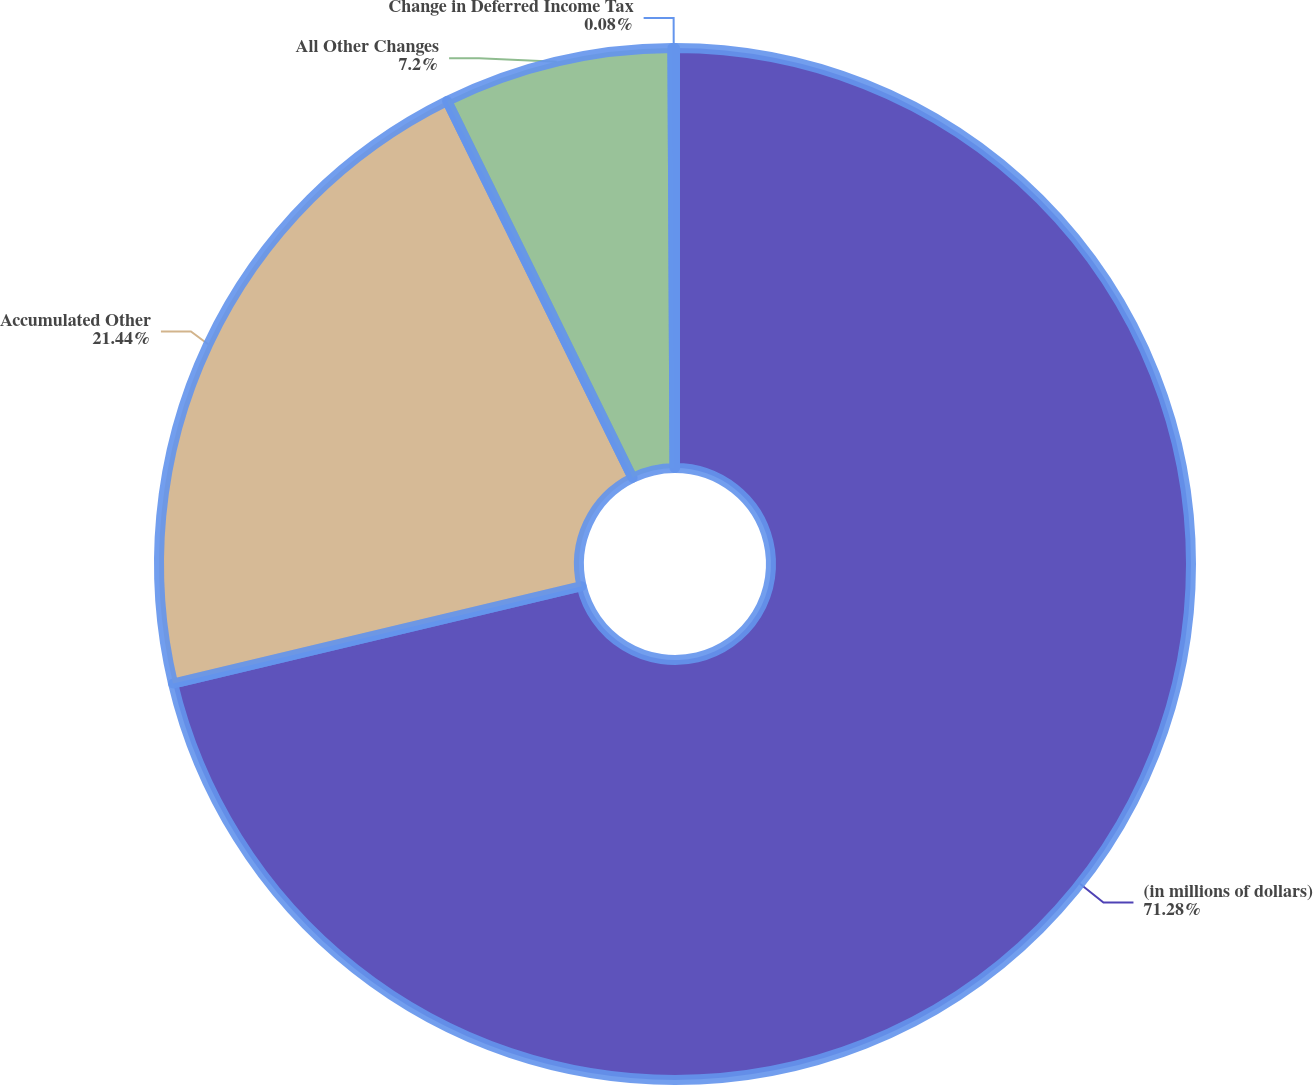Convert chart to OTSL. <chart><loc_0><loc_0><loc_500><loc_500><pie_chart><fcel>(in millions of dollars)<fcel>Accumulated Other<fcel>All Other Changes<fcel>Change in Deferred Income Tax<nl><fcel>71.28%<fcel>21.44%<fcel>7.2%<fcel>0.08%<nl></chart> 